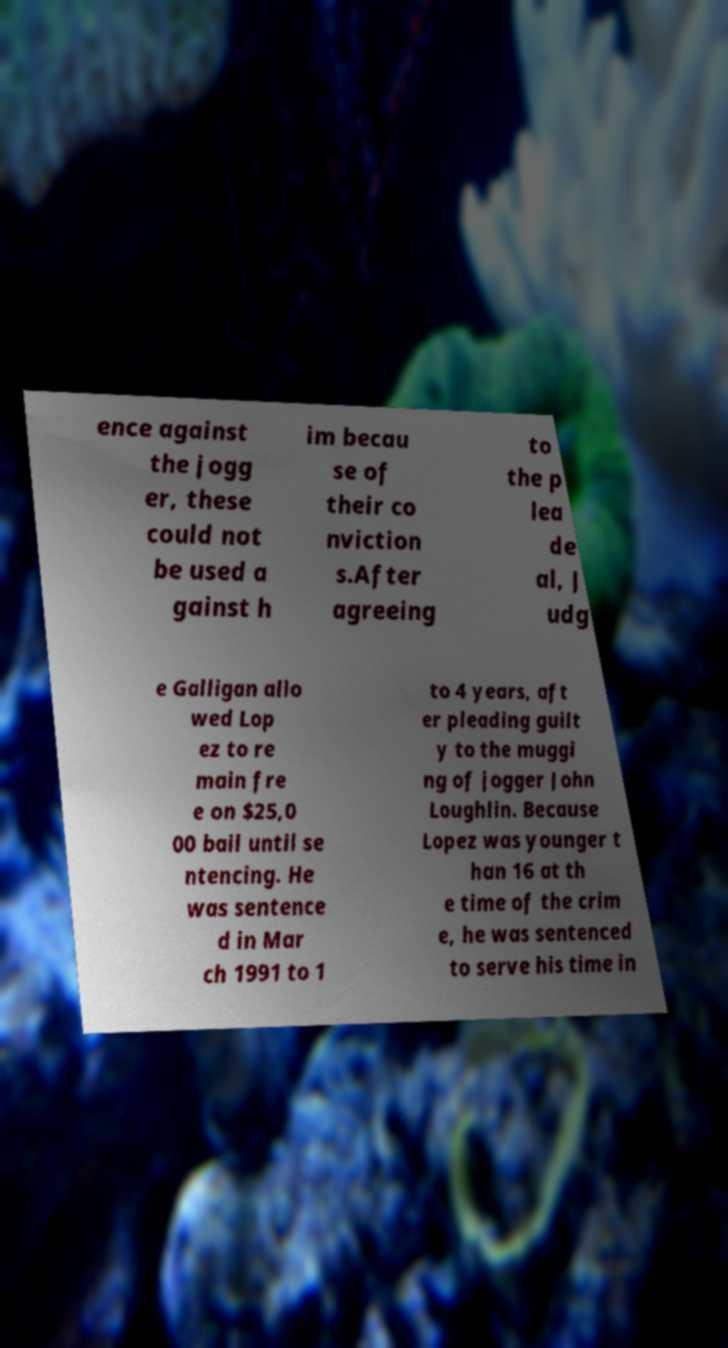For documentation purposes, I need the text within this image transcribed. Could you provide that? ence against the jogg er, these could not be used a gainst h im becau se of their co nviction s.After agreeing to the p lea de al, J udg e Galligan allo wed Lop ez to re main fre e on $25,0 00 bail until se ntencing. He was sentence d in Mar ch 1991 to 1 to 4 years, aft er pleading guilt y to the muggi ng of jogger John Loughlin. Because Lopez was younger t han 16 at th e time of the crim e, he was sentenced to serve his time in 